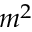Convert formula to latex. <formula><loc_0><loc_0><loc_500><loc_500>m ^ { 2 }</formula> 